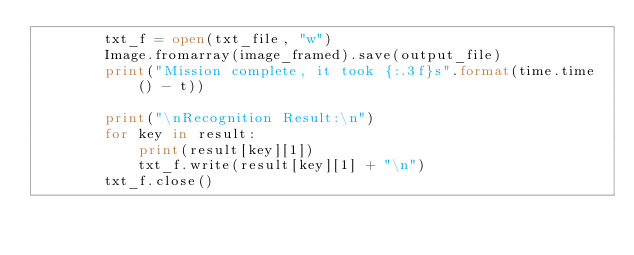Convert code to text. <code><loc_0><loc_0><loc_500><loc_500><_Python_>        txt_f = open(txt_file, "w")
        Image.fromarray(image_framed).save(output_file)
        print("Mission complete, it took {:.3f}s".format(time.time() - t))

        print("\nRecognition Result:\n")
        for key in result:
            print(result[key][1])
            txt_f.write(result[key][1] + "\n")
        txt_f.close()
</code> 